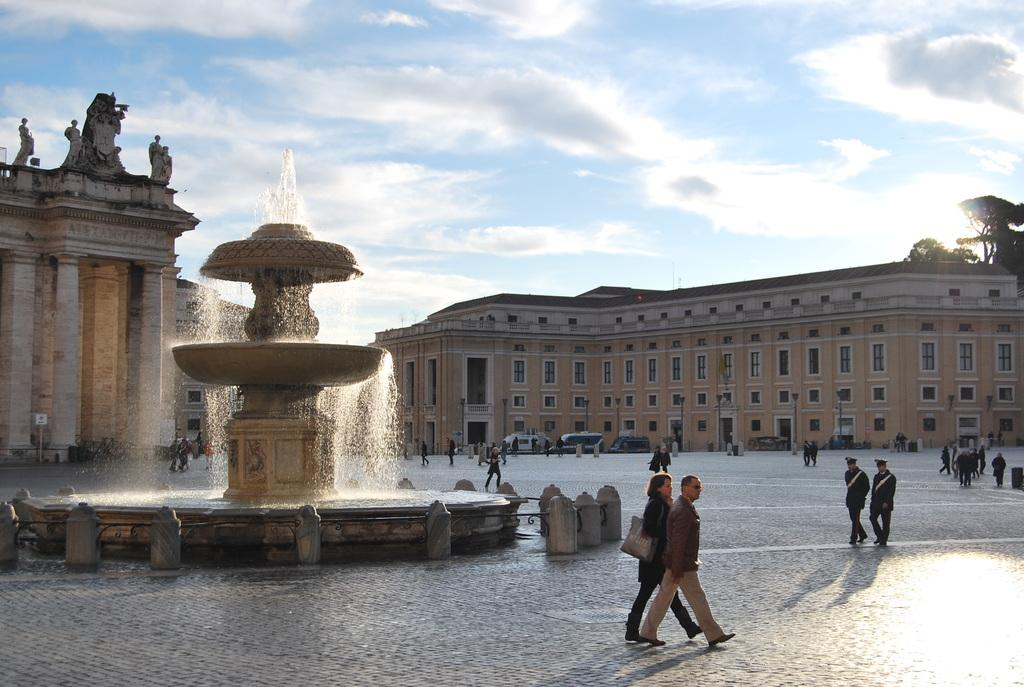What type of structures can be seen in the image? There are buildings in the image. What artistic features are present in the image? There are sculptures in the image. What type of water feature is visible in the image? There is a water fountain in the image. What type of vegetation is present in the image? There are trees in the image. What can be seen in the sky in the image? There are clouds in the sky, and the sky is visible in the image. What type of transportation is present in the image? There are vehicles in the image. Are there any people visible in the image? Yes, there are people standing in the image. What type of pen is being used by the animal in the image? There is no animal present in the image, and therefore no pen can be observed. What type of competition is taking place in the image? There is no competition present in the image. 